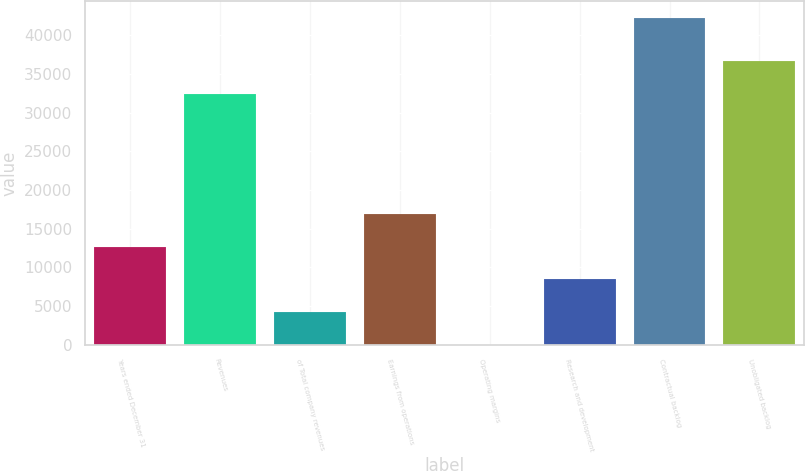<chart> <loc_0><loc_0><loc_500><loc_500><bar_chart><fcel>Years ended December 31<fcel>Revenues<fcel>of Total company revenues<fcel>Earnings from operations<fcel>Operating margins<fcel>Research and development<fcel>Contractual backlog<fcel>Unobligated backlog<nl><fcel>12692.7<fcel>32411<fcel>4237.16<fcel>16920.4<fcel>9.4<fcel>8464.92<fcel>42287<fcel>36638.8<nl></chart> 